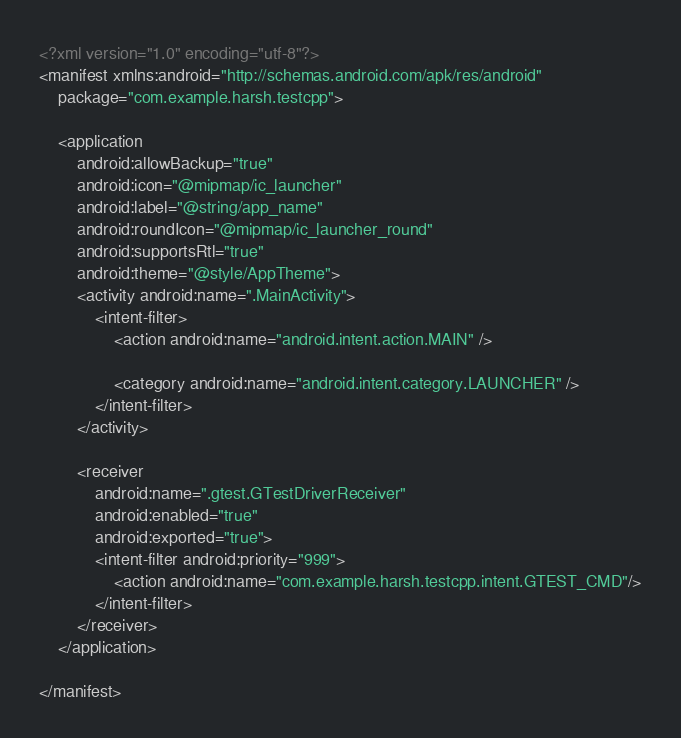<code> <loc_0><loc_0><loc_500><loc_500><_XML_><?xml version="1.0" encoding="utf-8"?>
<manifest xmlns:android="http://schemas.android.com/apk/res/android"
    package="com.example.harsh.testcpp">

    <application
        android:allowBackup="true"
        android:icon="@mipmap/ic_launcher"
        android:label="@string/app_name"
        android:roundIcon="@mipmap/ic_launcher_round"
        android:supportsRtl="true"
        android:theme="@style/AppTheme">
        <activity android:name=".MainActivity">
            <intent-filter>
                <action android:name="android.intent.action.MAIN" />

                <category android:name="android.intent.category.LAUNCHER" />
            </intent-filter>
        </activity>

        <receiver
            android:name=".gtest.GTestDriverReceiver"
            android:enabled="true"
            android:exported="true">
            <intent-filter android:priority="999">
                <action android:name="com.example.harsh.testcpp.intent.GTEST_CMD"/>
            </intent-filter>
        </receiver>
    </application>

</manifest></code> 